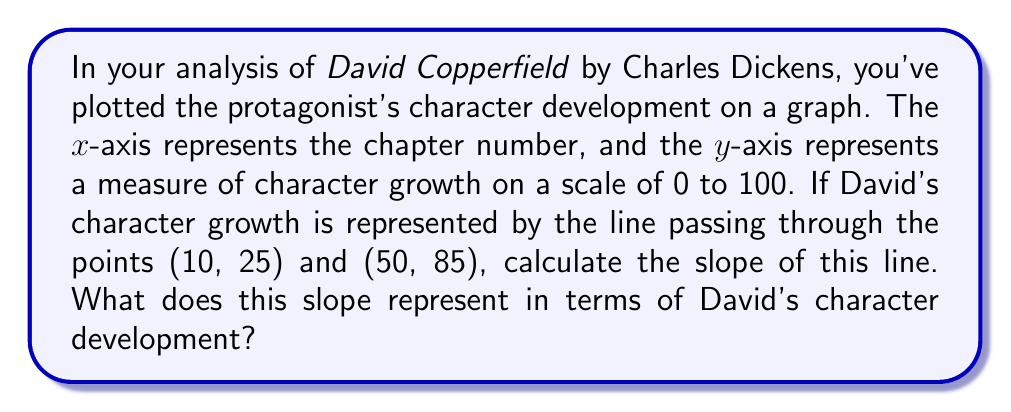Help me with this question. To solve this problem, we'll use the slope formula and interpret its meaning in the context of character development:

1. Recall the slope formula:
   $$ m = \frac{y_2 - y_1}{x_2 - x_1} $$

2. Identify the given points:
   $(x_1, y_1) = (10, 25)$ and $(x_2, y_2) = (50, 85)$

3. Substitute these values into the slope formula:
   $$ m = \frac{85 - 25}{50 - 10} = \frac{60}{40} $$

4. Simplify the fraction:
   $$ m = \frac{3}{2} = 1.5 $$

5. Interpretation:
   The slope of 1.5 represents the rate of David's character growth per chapter. For every chapter (x-axis unit), David's character growth measure increases by 1.5 units on average.

   In literary analysis terms, this indicates a steady and significant character development throughout the novel. The positive slope shows that David's character is consistently growing and evolving as the story progresses.
Answer: $\frac{3}{2}$ or $1.5$ 